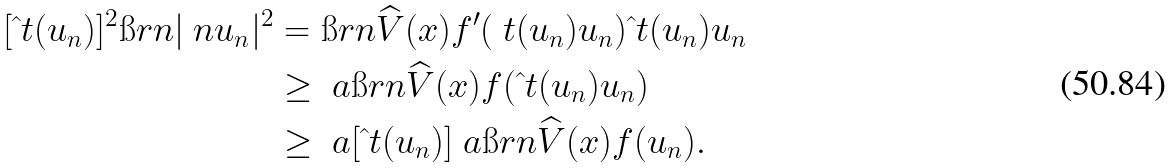<formula> <loc_0><loc_0><loc_500><loc_500>[ \hat { \ } t ( u _ { n } ) ] ^ { 2 } \i r n | \ n u _ { n } | ^ { 2 } & = \i r n \widehat { V } ( x ) f ^ { \prime } ( \ t ( u _ { n } ) u _ { n } ) \hat { \ } t ( u _ { n } ) u _ { n } \\ & \geq \ a \i r n \widehat { V } ( x ) f ( \hat { \ } t ( u _ { n } ) u _ { n } ) \\ & \geq \ a [ \hat { \ } t ( u _ { n } ) ] ^ { \ } a \i r n \widehat { V } ( x ) f ( u _ { n } ) .</formula> 